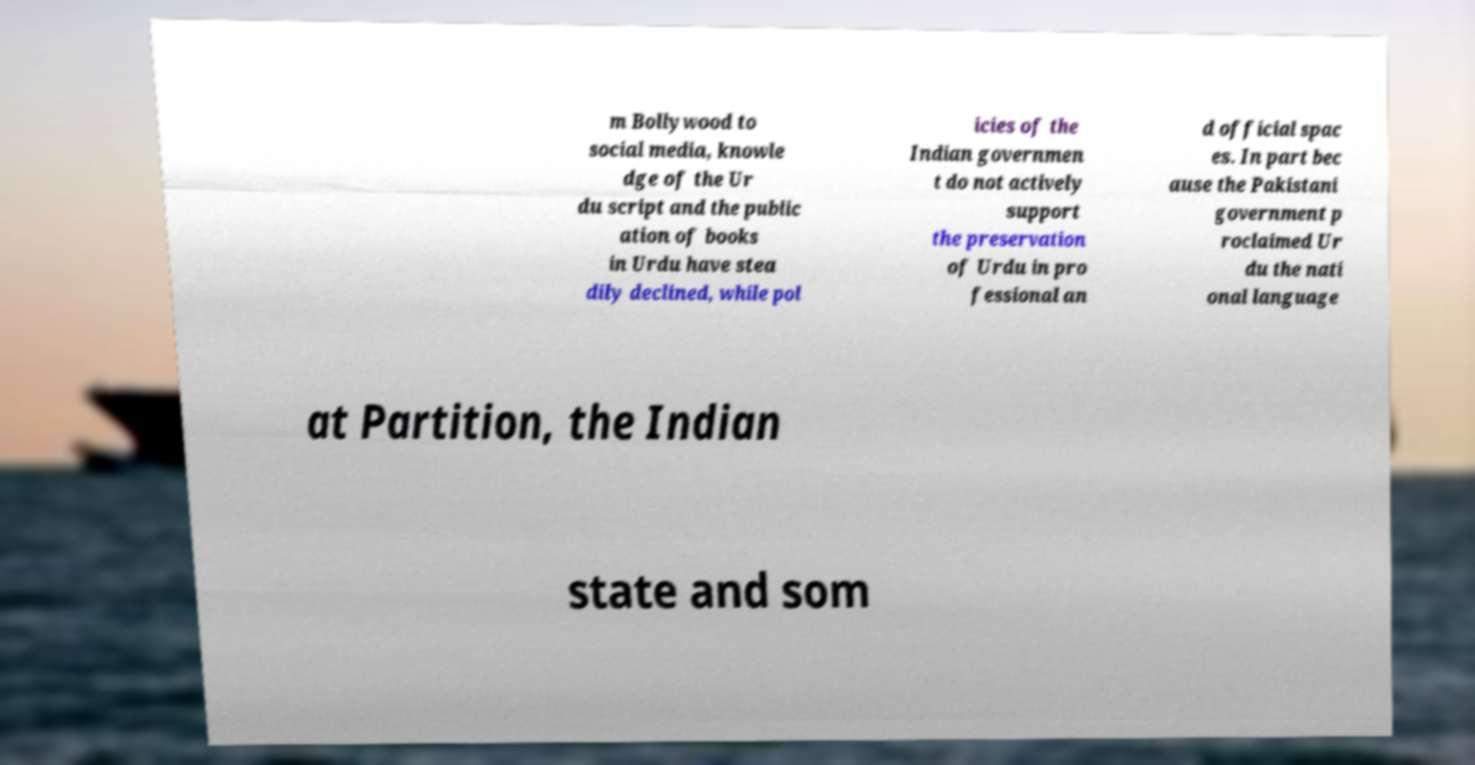Please identify and transcribe the text found in this image. m Bollywood to social media, knowle dge of the Ur du script and the public ation of books in Urdu have stea dily declined, while pol icies of the Indian governmen t do not actively support the preservation of Urdu in pro fessional an d official spac es. In part bec ause the Pakistani government p roclaimed Ur du the nati onal language at Partition, the Indian state and som 